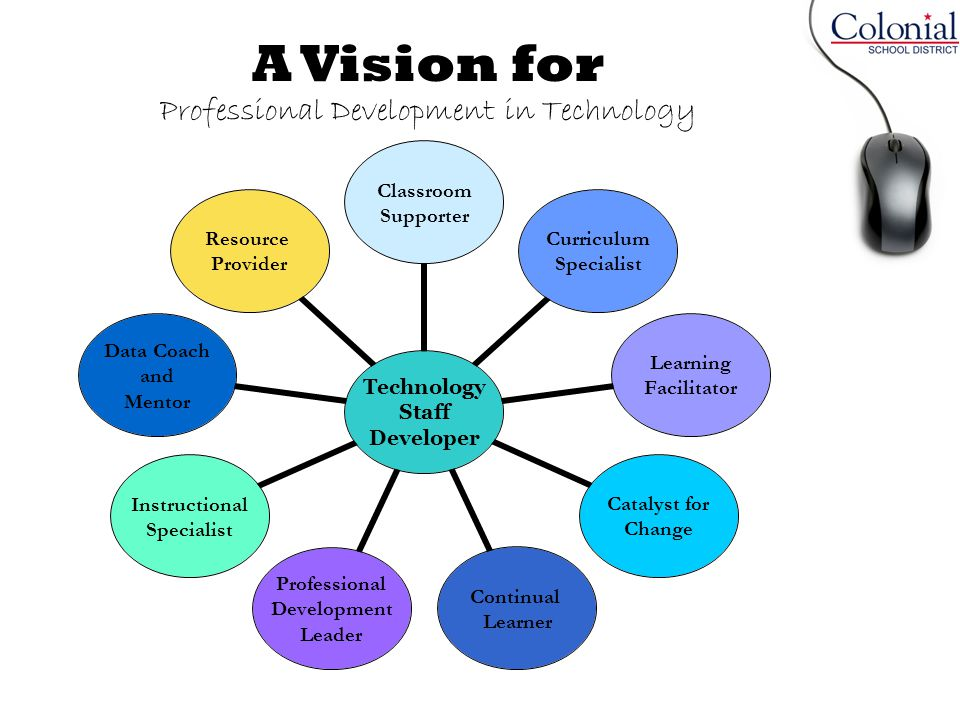What could be some specific tasks that a 'Resource Provider' might perform to support the technology vision outlined in this chart? A 'Resource Provider' may perform several tasks to support the technology vision, including sourcing and distributing educational technology tools and resources, providing training sessions on how to effectively use these tools, curating digital content and lesson plans that integrate technology, and troubleshooting technical issues to ensure smooth and continuous usage of technological resources. Additionally, they might collaborate with teachers and staff to identify the most effective resources tailored to the specific needs of their students. 